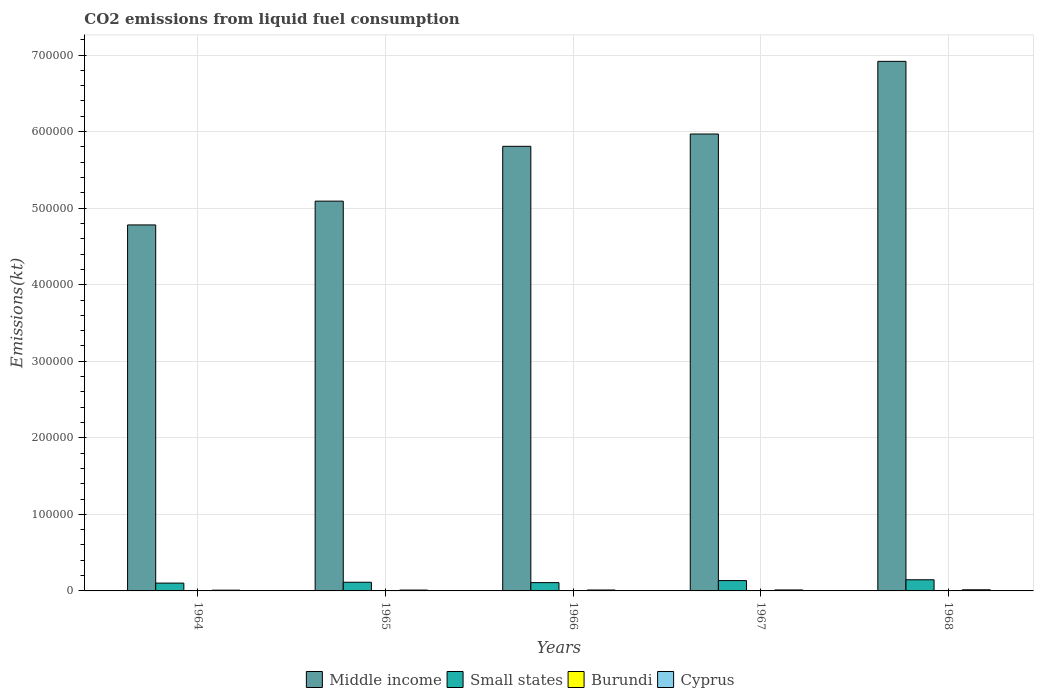How many different coloured bars are there?
Make the answer very short. 4. Are the number of bars on each tick of the X-axis equal?
Offer a very short reply. Yes. How many bars are there on the 2nd tick from the left?
Give a very brief answer. 4. How many bars are there on the 3rd tick from the right?
Provide a short and direct response. 4. What is the label of the 2nd group of bars from the left?
Keep it short and to the point. 1965. In how many cases, is the number of bars for a given year not equal to the number of legend labels?
Provide a succinct answer. 0. What is the amount of CO2 emitted in Middle income in 1968?
Ensure brevity in your answer.  6.92e+05. Across all years, what is the maximum amount of CO2 emitted in Small states?
Provide a short and direct response. 1.46e+04. Across all years, what is the minimum amount of CO2 emitted in Cyprus?
Your answer should be compact. 964.42. In which year was the amount of CO2 emitted in Burundi maximum?
Make the answer very short. 1968. In which year was the amount of CO2 emitted in Middle income minimum?
Your answer should be very brief. 1964. What is the total amount of CO2 emitted in Burundi in the graph?
Make the answer very short. 234.69. What is the difference between the amount of CO2 emitted in Middle income in 1964 and that in 1968?
Give a very brief answer. -2.14e+05. What is the difference between the amount of CO2 emitted in Cyprus in 1968 and the amount of CO2 emitted in Small states in 1966?
Your answer should be very brief. -9314.83. What is the average amount of CO2 emitted in Cyprus per year?
Provide a succinct answer. 1207.18. In the year 1966, what is the difference between the amount of CO2 emitted in Burundi and amount of CO2 emitted in Cyprus?
Your response must be concise. -1144.1. In how many years, is the amount of CO2 emitted in Middle income greater than 620000 kt?
Offer a terse response. 1. What is the ratio of the amount of CO2 emitted in Cyprus in 1967 to that in 1968?
Give a very brief answer. 0.85. Is the amount of CO2 emitted in Small states in 1964 less than that in 1968?
Provide a succinct answer. Yes. What is the difference between the highest and the second highest amount of CO2 emitted in Middle income?
Offer a terse response. 9.49e+04. What is the difference between the highest and the lowest amount of CO2 emitted in Small states?
Keep it short and to the point. 4363.16. In how many years, is the amount of CO2 emitted in Middle income greater than the average amount of CO2 emitted in Middle income taken over all years?
Make the answer very short. 3. What does the 4th bar from the left in 1968 represents?
Your answer should be compact. Cyprus. What does the 3rd bar from the right in 1966 represents?
Ensure brevity in your answer.  Small states. Is it the case that in every year, the sum of the amount of CO2 emitted in Burundi and amount of CO2 emitted in Cyprus is greater than the amount of CO2 emitted in Small states?
Provide a short and direct response. No. Are the values on the major ticks of Y-axis written in scientific E-notation?
Your response must be concise. No. Does the graph contain any zero values?
Keep it short and to the point. No. How are the legend labels stacked?
Your answer should be compact. Horizontal. What is the title of the graph?
Your answer should be very brief. CO2 emissions from liquid fuel consumption. Does "Burkina Faso" appear as one of the legend labels in the graph?
Offer a terse response. No. What is the label or title of the Y-axis?
Your answer should be compact. Emissions(kt). What is the Emissions(kt) of Middle income in 1964?
Keep it short and to the point. 4.78e+05. What is the Emissions(kt) in Small states in 1964?
Give a very brief answer. 1.02e+04. What is the Emissions(kt) in Burundi in 1964?
Ensure brevity in your answer.  47.67. What is the Emissions(kt) of Cyprus in 1964?
Your answer should be very brief. 964.42. What is the Emissions(kt) in Middle income in 1965?
Your answer should be very brief. 5.09e+05. What is the Emissions(kt) of Small states in 1965?
Keep it short and to the point. 1.13e+04. What is the Emissions(kt) in Burundi in 1965?
Your answer should be very brief. 36.67. What is the Emissions(kt) in Cyprus in 1965?
Offer a terse response. 1103.77. What is the Emissions(kt) in Middle income in 1966?
Your response must be concise. 5.81e+05. What is the Emissions(kt) of Small states in 1966?
Offer a terse response. 1.08e+04. What is the Emissions(kt) of Burundi in 1966?
Offer a terse response. 47.67. What is the Emissions(kt) in Cyprus in 1966?
Keep it short and to the point. 1191.78. What is the Emissions(kt) of Middle income in 1967?
Give a very brief answer. 5.97e+05. What is the Emissions(kt) in Small states in 1967?
Offer a very short reply. 1.35e+04. What is the Emissions(kt) in Burundi in 1967?
Your answer should be very brief. 47.67. What is the Emissions(kt) in Cyprus in 1967?
Give a very brief answer. 1272.45. What is the Emissions(kt) of Middle income in 1968?
Provide a short and direct response. 6.92e+05. What is the Emissions(kt) in Small states in 1968?
Ensure brevity in your answer.  1.46e+04. What is the Emissions(kt) in Burundi in 1968?
Your answer should be very brief. 55.01. What is the Emissions(kt) of Cyprus in 1968?
Ensure brevity in your answer.  1503.47. Across all years, what is the maximum Emissions(kt) of Middle income?
Keep it short and to the point. 6.92e+05. Across all years, what is the maximum Emissions(kt) in Small states?
Keep it short and to the point. 1.46e+04. Across all years, what is the maximum Emissions(kt) of Burundi?
Keep it short and to the point. 55.01. Across all years, what is the maximum Emissions(kt) in Cyprus?
Provide a succinct answer. 1503.47. Across all years, what is the minimum Emissions(kt) of Middle income?
Make the answer very short. 4.78e+05. Across all years, what is the minimum Emissions(kt) of Small states?
Provide a short and direct response. 1.02e+04. Across all years, what is the minimum Emissions(kt) of Burundi?
Provide a short and direct response. 36.67. Across all years, what is the minimum Emissions(kt) in Cyprus?
Give a very brief answer. 964.42. What is the total Emissions(kt) of Middle income in the graph?
Your answer should be very brief. 2.86e+06. What is the total Emissions(kt) in Small states in the graph?
Provide a short and direct response. 6.04e+04. What is the total Emissions(kt) of Burundi in the graph?
Provide a short and direct response. 234.69. What is the total Emissions(kt) in Cyprus in the graph?
Your answer should be compact. 6035.88. What is the difference between the Emissions(kt) in Middle income in 1964 and that in 1965?
Your answer should be compact. -3.11e+04. What is the difference between the Emissions(kt) of Small states in 1964 and that in 1965?
Give a very brief answer. -1133.64. What is the difference between the Emissions(kt) of Burundi in 1964 and that in 1965?
Keep it short and to the point. 11. What is the difference between the Emissions(kt) in Cyprus in 1964 and that in 1965?
Offer a terse response. -139.35. What is the difference between the Emissions(kt) of Middle income in 1964 and that in 1966?
Your response must be concise. -1.03e+05. What is the difference between the Emissions(kt) of Small states in 1964 and that in 1966?
Ensure brevity in your answer.  -611.62. What is the difference between the Emissions(kt) in Burundi in 1964 and that in 1966?
Make the answer very short. 0. What is the difference between the Emissions(kt) in Cyprus in 1964 and that in 1966?
Your answer should be very brief. -227.35. What is the difference between the Emissions(kt) in Middle income in 1964 and that in 1967?
Keep it short and to the point. -1.19e+05. What is the difference between the Emissions(kt) of Small states in 1964 and that in 1967?
Your response must be concise. -3284.06. What is the difference between the Emissions(kt) in Cyprus in 1964 and that in 1967?
Offer a very short reply. -308.03. What is the difference between the Emissions(kt) in Middle income in 1964 and that in 1968?
Offer a terse response. -2.14e+05. What is the difference between the Emissions(kt) in Small states in 1964 and that in 1968?
Keep it short and to the point. -4363.16. What is the difference between the Emissions(kt) in Burundi in 1964 and that in 1968?
Give a very brief answer. -7.33. What is the difference between the Emissions(kt) of Cyprus in 1964 and that in 1968?
Ensure brevity in your answer.  -539.05. What is the difference between the Emissions(kt) in Middle income in 1965 and that in 1966?
Your response must be concise. -7.16e+04. What is the difference between the Emissions(kt) in Small states in 1965 and that in 1966?
Offer a very short reply. 522.02. What is the difference between the Emissions(kt) in Burundi in 1965 and that in 1966?
Provide a succinct answer. -11. What is the difference between the Emissions(kt) of Cyprus in 1965 and that in 1966?
Give a very brief answer. -88.01. What is the difference between the Emissions(kt) in Middle income in 1965 and that in 1967?
Offer a very short reply. -8.77e+04. What is the difference between the Emissions(kt) in Small states in 1965 and that in 1967?
Your answer should be very brief. -2150.42. What is the difference between the Emissions(kt) in Burundi in 1965 and that in 1967?
Ensure brevity in your answer.  -11. What is the difference between the Emissions(kt) in Cyprus in 1965 and that in 1967?
Make the answer very short. -168.68. What is the difference between the Emissions(kt) of Middle income in 1965 and that in 1968?
Provide a short and direct response. -1.83e+05. What is the difference between the Emissions(kt) of Small states in 1965 and that in 1968?
Offer a very short reply. -3229.52. What is the difference between the Emissions(kt) in Burundi in 1965 and that in 1968?
Offer a terse response. -18.34. What is the difference between the Emissions(kt) of Cyprus in 1965 and that in 1968?
Offer a very short reply. -399.7. What is the difference between the Emissions(kt) in Middle income in 1966 and that in 1967?
Ensure brevity in your answer.  -1.61e+04. What is the difference between the Emissions(kt) of Small states in 1966 and that in 1967?
Your response must be concise. -2672.44. What is the difference between the Emissions(kt) in Burundi in 1966 and that in 1967?
Your answer should be very brief. 0. What is the difference between the Emissions(kt) in Cyprus in 1966 and that in 1967?
Provide a short and direct response. -80.67. What is the difference between the Emissions(kt) in Middle income in 1966 and that in 1968?
Give a very brief answer. -1.11e+05. What is the difference between the Emissions(kt) in Small states in 1966 and that in 1968?
Your response must be concise. -3751.54. What is the difference between the Emissions(kt) in Burundi in 1966 and that in 1968?
Make the answer very short. -7.33. What is the difference between the Emissions(kt) of Cyprus in 1966 and that in 1968?
Provide a succinct answer. -311.69. What is the difference between the Emissions(kt) in Middle income in 1967 and that in 1968?
Provide a short and direct response. -9.49e+04. What is the difference between the Emissions(kt) of Small states in 1967 and that in 1968?
Your answer should be compact. -1079.1. What is the difference between the Emissions(kt) of Burundi in 1967 and that in 1968?
Your answer should be compact. -7.33. What is the difference between the Emissions(kt) in Cyprus in 1967 and that in 1968?
Your answer should be very brief. -231.02. What is the difference between the Emissions(kt) of Middle income in 1964 and the Emissions(kt) of Small states in 1965?
Give a very brief answer. 4.67e+05. What is the difference between the Emissions(kt) of Middle income in 1964 and the Emissions(kt) of Burundi in 1965?
Your answer should be very brief. 4.78e+05. What is the difference between the Emissions(kt) in Middle income in 1964 and the Emissions(kt) in Cyprus in 1965?
Offer a very short reply. 4.77e+05. What is the difference between the Emissions(kt) of Small states in 1964 and the Emissions(kt) of Burundi in 1965?
Ensure brevity in your answer.  1.02e+04. What is the difference between the Emissions(kt) in Small states in 1964 and the Emissions(kt) in Cyprus in 1965?
Ensure brevity in your answer.  9102.92. What is the difference between the Emissions(kt) of Burundi in 1964 and the Emissions(kt) of Cyprus in 1965?
Ensure brevity in your answer.  -1056.1. What is the difference between the Emissions(kt) in Middle income in 1964 and the Emissions(kt) in Small states in 1966?
Offer a terse response. 4.67e+05. What is the difference between the Emissions(kt) in Middle income in 1964 and the Emissions(kt) in Burundi in 1966?
Provide a succinct answer. 4.78e+05. What is the difference between the Emissions(kt) in Middle income in 1964 and the Emissions(kt) in Cyprus in 1966?
Provide a succinct answer. 4.77e+05. What is the difference between the Emissions(kt) in Small states in 1964 and the Emissions(kt) in Burundi in 1966?
Give a very brief answer. 1.02e+04. What is the difference between the Emissions(kt) of Small states in 1964 and the Emissions(kt) of Cyprus in 1966?
Provide a short and direct response. 9014.91. What is the difference between the Emissions(kt) of Burundi in 1964 and the Emissions(kt) of Cyprus in 1966?
Make the answer very short. -1144.1. What is the difference between the Emissions(kt) in Middle income in 1964 and the Emissions(kt) in Small states in 1967?
Make the answer very short. 4.65e+05. What is the difference between the Emissions(kt) of Middle income in 1964 and the Emissions(kt) of Burundi in 1967?
Your response must be concise. 4.78e+05. What is the difference between the Emissions(kt) in Middle income in 1964 and the Emissions(kt) in Cyprus in 1967?
Your answer should be very brief. 4.77e+05. What is the difference between the Emissions(kt) of Small states in 1964 and the Emissions(kt) of Burundi in 1967?
Give a very brief answer. 1.02e+04. What is the difference between the Emissions(kt) in Small states in 1964 and the Emissions(kt) in Cyprus in 1967?
Provide a short and direct response. 8934.23. What is the difference between the Emissions(kt) of Burundi in 1964 and the Emissions(kt) of Cyprus in 1967?
Provide a short and direct response. -1224.78. What is the difference between the Emissions(kt) of Middle income in 1964 and the Emissions(kt) of Small states in 1968?
Offer a very short reply. 4.64e+05. What is the difference between the Emissions(kt) of Middle income in 1964 and the Emissions(kt) of Burundi in 1968?
Make the answer very short. 4.78e+05. What is the difference between the Emissions(kt) in Middle income in 1964 and the Emissions(kt) in Cyprus in 1968?
Provide a succinct answer. 4.77e+05. What is the difference between the Emissions(kt) of Small states in 1964 and the Emissions(kt) of Burundi in 1968?
Give a very brief answer. 1.02e+04. What is the difference between the Emissions(kt) in Small states in 1964 and the Emissions(kt) in Cyprus in 1968?
Offer a terse response. 8703.21. What is the difference between the Emissions(kt) in Burundi in 1964 and the Emissions(kt) in Cyprus in 1968?
Keep it short and to the point. -1455.8. What is the difference between the Emissions(kt) in Middle income in 1965 and the Emissions(kt) in Small states in 1966?
Your response must be concise. 4.98e+05. What is the difference between the Emissions(kt) in Middle income in 1965 and the Emissions(kt) in Burundi in 1966?
Make the answer very short. 5.09e+05. What is the difference between the Emissions(kt) of Middle income in 1965 and the Emissions(kt) of Cyprus in 1966?
Your answer should be compact. 5.08e+05. What is the difference between the Emissions(kt) in Small states in 1965 and the Emissions(kt) in Burundi in 1966?
Ensure brevity in your answer.  1.13e+04. What is the difference between the Emissions(kt) in Small states in 1965 and the Emissions(kt) in Cyprus in 1966?
Ensure brevity in your answer.  1.01e+04. What is the difference between the Emissions(kt) of Burundi in 1965 and the Emissions(kt) of Cyprus in 1966?
Offer a terse response. -1155.11. What is the difference between the Emissions(kt) in Middle income in 1965 and the Emissions(kt) in Small states in 1967?
Make the answer very short. 4.96e+05. What is the difference between the Emissions(kt) in Middle income in 1965 and the Emissions(kt) in Burundi in 1967?
Keep it short and to the point. 5.09e+05. What is the difference between the Emissions(kt) in Middle income in 1965 and the Emissions(kt) in Cyprus in 1967?
Keep it short and to the point. 5.08e+05. What is the difference between the Emissions(kt) of Small states in 1965 and the Emissions(kt) of Burundi in 1967?
Provide a succinct answer. 1.13e+04. What is the difference between the Emissions(kt) of Small states in 1965 and the Emissions(kt) of Cyprus in 1967?
Your answer should be compact. 1.01e+04. What is the difference between the Emissions(kt) of Burundi in 1965 and the Emissions(kt) of Cyprus in 1967?
Provide a short and direct response. -1235.78. What is the difference between the Emissions(kt) in Middle income in 1965 and the Emissions(kt) in Small states in 1968?
Provide a succinct answer. 4.95e+05. What is the difference between the Emissions(kt) in Middle income in 1965 and the Emissions(kt) in Burundi in 1968?
Ensure brevity in your answer.  5.09e+05. What is the difference between the Emissions(kt) in Middle income in 1965 and the Emissions(kt) in Cyprus in 1968?
Your response must be concise. 5.08e+05. What is the difference between the Emissions(kt) in Small states in 1965 and the Emissions(kt) in Burundi in 1968?
Provide a short and direct response. 1.13e+04. What is the difference between the Emissions(kt) of Small states in 1965 and the Emissions(kt) of Cyprus in 1968?
Offer a very short reply. 9836.85. What is the difference between the Emissions(kt) in Burundi in 1965 and the Emissions(kt) in Cyprus in 1968?
Your response must be concise. -1466.8. What is the difference between the Emissions(kt) in Middle income in 1966 and the Emissions(kt) in Small states in 1967?
Your answer should be very brief. 5.67e+05. What is the difference between the Emissions(kt) in Middle income in 1966 and the Emissions(kt) in Burundi in 1967?
Keep it short and to the point. 5.81e+05. What is the difference between the Emissions(kt) in Middle income in 1966 and the Emissions(kt) in Cyprus in 1967?
Provide a succinct answer. 5.80e+05. What is the difference between the Emissions(kt) in Small states in 1966 and the Emissions(kt) in Burundi in 1967?
Ensure brevity in your answer.  1.08e+04. What is the difference between the Emissions(kt) of Small states in 1966 and the Emissions(kt) of Cyprus in 1967?
Ensure brevity in your answer.  9545.85. What is the difference between the Emissions(kt) of Burundi in 1966 and the Emissions(kt) of Cyprus in 1967?
Keep it short and to the point. -1224.78. What is the difference between the Emissions(kt) of Middle income in 1966 and the Emissions(kt) of Small states in 1968?
Your answer should be compact. 5.66e+05. What is the difference between the Emissions(kt) of Middle income in 1966 and the Emissions(kt) of Burundi in 1968?
Keep it short and to the point. 5.81e+05. What is the difference between the Emissions(kt) in Middle income in 1966 and the Emissions(kt) in Cyprus in 1968?
Provide a succinct answer. 5.79e+05. What is the difference between the Emissions(kt) in Small states in 1966 and the Emissions(kt) in Burundi in 1968?
Give a very brief answer. 1.08e+04. What is the difference between the Emissions(kt) of Small states in 1966 and the Emissions(kt) of Cyprus in 1968?
Provide a succinct answer. 9314.83. What is the difference between the Emissions(kt) in Burundi in 1966 and the Emissions(kt) in Cyprus in 1968?
Offer a very short reply. -1455.8. What is the difference between the Emissions(kt) of Middle income in 1967 and the Emissions(kt) of Small states in 1968?
Provide a short and direct response. 5.82e+05. What is the difference between the Emissions(kt) in Middle income in 1967 and the Emissions(kt) in Burundi in 1968?
Keep it short and to the point. 5.97e+05. What is the difference between the Emissions(kt) of Middle income in 1967 and the Emissions(kt) of Cyprus in 1968?
Provide a short and direct response. 5.95e+05. What is the difference between the Emissions(kt) of Small states in 1967 and the Emissions(kt) of Burundi in 1968?
Give a very brief answer. 1.34e+04. What is the difference between the Emissions(kt) of Small states in 1967 and the Emissions(kt) of Cyprus in 1968?
Your response must be concise. 1.20e+04. What is the difference between the Emissions(kt) in Burundi in 1967 and the Emissions(kt) in Cyprus in 1968?
Provide a succinct answer. -1455.8. What is the average Emissions(kt) of Middle income per year?
Ensure brevity in your answer.  5.71e+05. What is the average Emissions(kt) of Small states per year?
Offer a very short reply. 1.21e+04. What is the average Emissions(kt) of Burundi per year?
Give a very brief answer. 46.94. What is the average Emissions(kt) in Cyprus per year?
Provide a succinct answer. 1207.18. In the year 1964, what is the difference between the Emissions(kt) in Middle income and Emissions(kt) in Small states?
Offer a terse response. 4.68e+05. In the year 1964, what is the difference between the Emissions(kt) in Middle income and Emissions(kt) in Burundi?
Offer a terse response. 4.78e+05. In the year 1964, what is the difference between the Emissions(kt) of Middle income and Emissions(kt) of Cyprus?
Provide a succinct answer. 4.77e+05. In the year 1964, what is the difference between the Emissions(kt) in Small states and Emissions(kt) in Burundi?
Ensure brevity in your answer.  1.02e+04. In the year 1964, what is the difference between the Emissions(kt) in Small states and Emissions(kt) in Cyprus?
Offer a terse response. 9242.26. In the year 1964, what is the difference between the Emissions(kt) in Burundi and Emissions(kt) in Cyprus?
Offer a very short reply. -916.75. In the year 1965, what is the difference between the Emissions(kt) of Middle income and Emissions(kt) of Small states?
Provide a succinct answer. 4.98e+05. In the year 1965, what is the difference between the Emissions(kt) of Middle income and Emissions(kt) of Burundi?
Provide a succinct answer. 5.09e+05. In the year 1965, what is the difference between the Emissions(kt) in Middle income and Emissions(kt) in Cyprus?
Keep it short and to the point. 5.08e+05. In the year 1965, what is the difference between the Emissions(kt) of Small states and Emissions(kt) of Burundi?
Keep it short and to the point. 1.13e+04. In the year 1965, what is the difference between the Emissions(kt) in Small states and Emissions(kt) in Cyprus?
Make the answer very short. 1.02e+04. In the year 1965, what is the difference between the Emissions(kt) in Burundi and Emissions(kt) in Cyprus?
Your answer should be very brief. -1067.1. In the year 1966, what is the difference between the Emissions(kt) in Middle income and Emissions(kt) in Small states?
Offer a very short reply. 5.70e+05. In the year 1966, what is the difference between the Emissions(kt) of Middle income and Emissions(kt) of Burundi?
Offer a very short reply. 5.81e+05. In the year 1966, what is the difference between the Emissions(kt) in Middle income and Emissions(kt) in Cyprus?
Offer a very short reply. 5.80e+05. In the year 1966, what is the difference between the Emissions(kt) of Small states and Emissions(kt) of Burundi?
Ensure brevity in your answer.  1.08e+04. In the year 1966, what is the difference between the Emissions(kt) in Small states and Emissions(kt) in Cyprus?
Provide a short and direct response. 9626.53. In the year 1966, what is the difference between the Emissions(kt) in Burundi and Emissions(kt) in Cyprus?
Offer a very short reply. -1144.1. In the year 1967, what is the difference between the Emissions(kt) in Middle income and Emissions(kt) in Small states?
Your answer should be very brief. 5.83e+05. In the year 1967, what is the difference between the Emissions(kt) of Middle income and Emissions(kt) of Burundi?
Ensure brevity in your answer.  5.97e+05. In the year 1967, what is the difference between the Emissions(kt) of Middle income and Emissions(kt) of Cyprus?
Make the answer very short. 5.96e+05. In the year 1967, what is the difference between the Emissions(kt) in Small states and Emissions(kt) in Burundi?
Provide a short and direct response. 1.34e+04. In the year 1967, what is the difference between the Emissions(kt) in Small states and Emissions(kt) in Cyprus?
Offer a terse response. 1.22e+04. In the year 1967, what is the difference between the Emissions(kt) of Burundi and Emissions(kt) of Cyprus?
Keep it short and to the point. -1224.78. In the year 1968, what is the difference between the Emissions(kt) of Middle income and Emissions(kt) of Small states?
Provide a short and direct response. 6.77e+05. In the year 1968, what is the difference between the Emissions(kt) in Middle income and Emissions(kt) in Burundi?
Provide a short and direct response. 6.92e+05. In the year 1968, what is the difference between the Emissions(kt) of Middle income and Emissions(kt) of Cyprus?
Your response must be concise. 6.90e+05. In the year 1968, what is the difference between the Emissions(kt) of Small states and Emissions(kt) of Burundi?
Keep it short and to the point. 1.45e+04. In the year 1968, what is the difference between the Emissions(kt) of Small states and Emissions(kt) of Cyprus?
Your response must be concise. 1.31e+04. In the year 1968, what is the difference between the Emissions(kt) of Burundi and Emissions(kt) of Cyprus?
Make the answer very short. -1448.46. What is the ratio of the Emissions(kt) of Middle income in 1964 to that in 1965?
Your answer should be compact. 0.94. What is the ratio of the Emissions(kt) of Burundi in 1964 to that in 1965?
Provide a short and direct response. 1.3. What is the ratio of the Emissions(kt) in Cyprus in 1964 to that in 1965?
Your answer should be compact. 0.87. What is the ratio of the Emissions(kt) of Middle income in 1964 to that in 1966?
Offer a very short reply. 0.82. What is the ratio of the Emissions(kt) of Small states in 1964 to that in 1966?
Provide a succinct answer. 0.94. What is the ratio of the Emissions(kt) of Cyprus in 1964 to that in 1966?
Provide a succinct answer. 0.81. What is the ratio of the Emissions(kt) of Middle income in 1964 to that in 1967?
Offer a terse response. 0.8. What is the ratio of the Emissions(kt) in Small states in 1964 to that in 1967?
Make the answer very short. 0.76. What is the ratio of the Emissions(kt) in Cyprus in 1964 to that in 1967?
Give a very brief answer. 0.76. What is the ratio of the Emissions(kt) in Middle income in 1964 to that in 1968?
Give a very brief answer. 0.69. What is the ratio of the Emissions(kt) of Small states in 1964 to that in 1968?
Your response must be concise. 0.7. What is the ratio of the Emissions(kt) in Burundi in 1964 to that in 1968?
Make the answer very short. 0.87. What is the ratio of the Emissions(kt) in Cyprus in 1964 to that in 1968?
Offer a terse response. 0.64. What is the ratio of the Emissions(kt) in Middle income in 1965 to that in 1966?
Keep it short and to the point. 0.88. What is the ratio of the Emissions(kt) in Small states in 1965 to that in 1966?
Make the answer very short. 1.05. What is the ratio of the Emissions(kt) of Burundi in 1965 to that in 1966?
Ensure brevity in your answer.  0.77. What is the ratio of the Emissions(kt) of Cyprus in 1965 to that in 1966?
Offer a very short reply. 0.93. What is the ratio of the Emissions(kt) of Middle income in 1965 to that in 1967?
Your answer should be compact. 0.85. What is the ratio of the Emissions(kt) in Small states in 1965 to that in 1967?
Your answer should be compact. 0.84. What is the ratio of the Emissions(kt) of Burundi in 1965 to that in 1967?
Offer a very short reply. 0.77. What is the ratio of the Emissions(kt) in Cyprus in 1965 to that in 1967?
Provide a short and direct response. 0.87. What is the ratio of the Emissions(kt) of Middle income in 1965 to that in 1968?
Provide a succinct answer. 0.74. What is the ratio of the Emissions(kt) of Small states in 1965 to that in 1968?
Your answer should be compact. 0.78. What is the ratio of the Emissions(kt) of Burundi in 1965 to that in 1968?
Offer a very short reply. 0.67. What is the ratio of the Emissions(kt) of Cyprus in 1965 to that in 1968?
Ensure brevity in your answer.  0.73. What is the ratio of the Emissions(kt) in Middle income in 1966 to that in 1967?
Keep it short and to the point. 0.97. What is the ratio of the Emissions(kt) in Small states in 1966 to that in 1967?
Keep it short and to the point. 0.8. What is the ratio of the Emissions(kt) in Cyprus in 1966 to that in 1967?
Give a very brief answer. 0.94. What is the ratio of the Emissions(kt) in Middle income in 1966 to that in 1968?
Offer a terse response. 0.84. What is the ratio of the Emissions(kt) in Small states in 1966 to that in 1968?
Provide a succinct answer. 0.74. What is the ratio of the Emissions(kt) in Burundi in 1966 to that in 1968?
Ensure brevity in your answer.  0.87. What is the ratio of the Emissions(kt) of Cyprus in 1966 to that in 1968?
Your answer should be very brief. 0.79. What is the ratio of the Emissions(kt) of Middle income in 1967 to that in 1968?
Provide a short and direct response. 0.86. What is the ratio of the Emissions(kt) of Small states in 1967 to that in 1968?
Give a very brief answer. 0.93. What is the ratio of the Emissions(kt) of Burundi in 1967 to that in 1968?
Your response must be concise. 0.87. What is the ratio of the Emissions(kt) of Cyprus in 1967 to that in 1968?
Ensure brevity in your answer.  0.85. What is the difference between the highest and the second highest Emissions(kt) of Middle income?
Give a very brief answer. 9.49e+04. What is the difference between the highest and the second highest Emissions(kt) of Small states?
Provide a succinct answer. 1079.1. What is the difference between the highest and the second highest Emissions(kt) in Burundi?
Your answer should be very brief. 7.33. What is the difference between the highest and the second highest Emissions(kt) of Cyprus?
Ensure brevity in your answer.  231.02. What is the difference between the highest and the lowest Emissions(kt) in Middle income?
Provide a short and direct response. 2.14e+05. What is the difference between the highest and the lowest Emissions(kt) in Small states?
Your response must be concise. 4363.16. What is the difference between the highest and the lowest Emissions(kt) of Burundi?
Provide a short and direct response. 18.34. What is the difference between the highest and the lowest Emissions(kt) of Cyprus?
Provide a short and direct response. 539.05. 